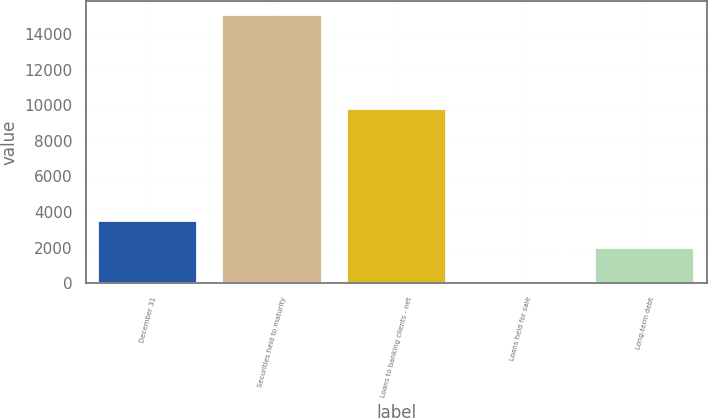Convert chart. <chart><loc_0><loc_0><loc_500><loc_500><bar_chart><fcel>December 31<fcel>Securities held to maturity<fcel>Loans to banking clients - net<fcel>Loans held for sale<fcel>Long-term debt<nl><fcel>3504.8<fcel>15108<fcel>9812<fcel>70<fcel>2001<nl></chart> 